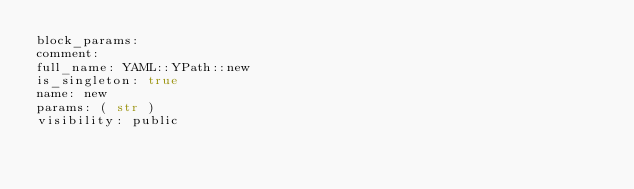Convert code to text. <code><loc_0><loc_0><loc_500><loc_500><_YAML_>block_params: 
comment: 
full_name: YAML::YPath::new
is_singleton: true
name: new
params: ( str )
visibility: public
</code> 